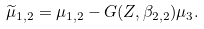<formula> <loc_0><loc_0><loc_500><loc_500>\widetilde { \mu } _ { 1 , 2 } = \mu _ { 1 , 2 } - G ( Z , \beta _ { 2 , 2 } ) \mu _ { 3 } .</formula> 